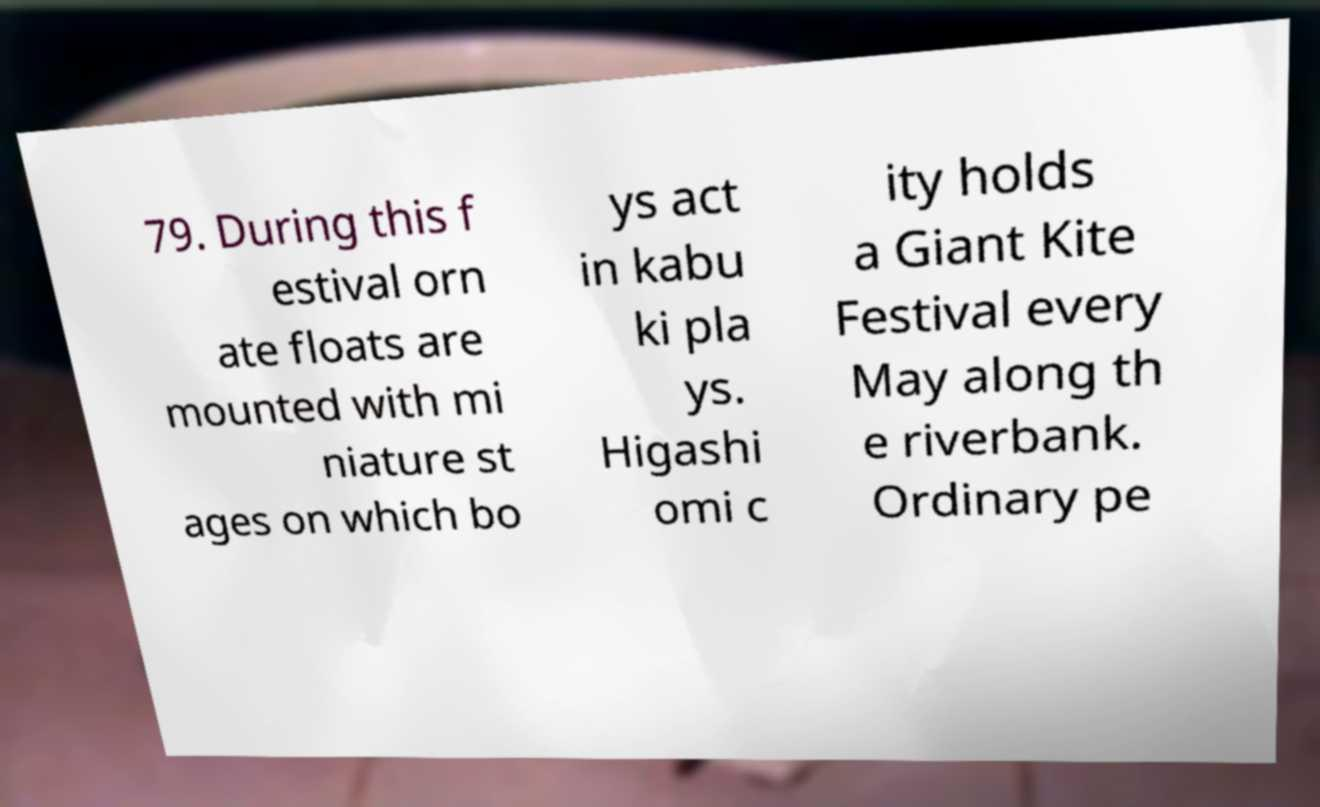Can you accurately transcribe the text from the provided image for me? 79. During this f estival orn ate floats are mounted with mi niature st ages on which bo ys act in kabu ki pla ys. Higashi omi c ity holds a Giant Kite Festival every May along th e riverbank. Ordinary pe 